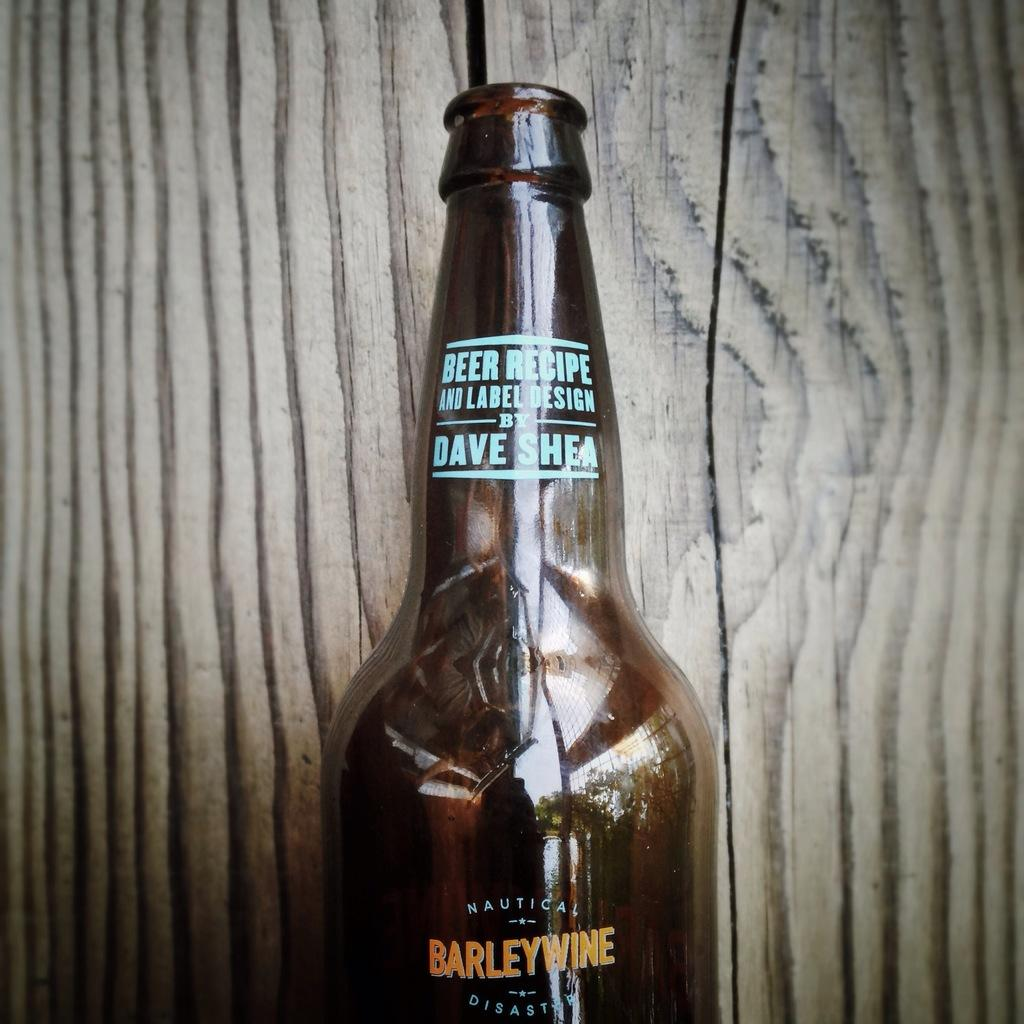What object can be seen in the picture? There is a bottle in the picture. What is the color of the bottle? The bottle is brown in color. Can you describe the background of the image? The background of the image has black shades. Is there a heart-shaped crack visible on the bottle in the image? There is no mention of a crack or a heart-shaped object in the image, so we cannot confirm its presence. 